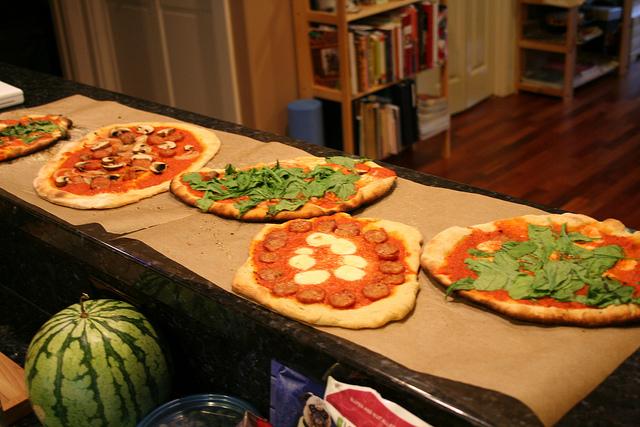Are these pizzas ready to be eaten?
Write a very short answer. No. What fruit is shown?
Be succinct. Watermelon. Which of these would you prefer to eat?
Answer briefly. Pepperoni. Is there a glass of beer nearby?
Answer briefly. No. Are these pizzas homemade?
Short answer required. Yes. 